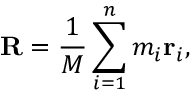<formula> <loc_0><loc_0><loc_500><loc_500>R = { \frac { 1 } { M } } \sum _ { i = 1 } ^ { n } m _ { i } r _ { i } ,</formula> 